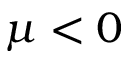<formula> <loc_0><loc_0><loc_500><loc_500>\mu < 0</formula> 